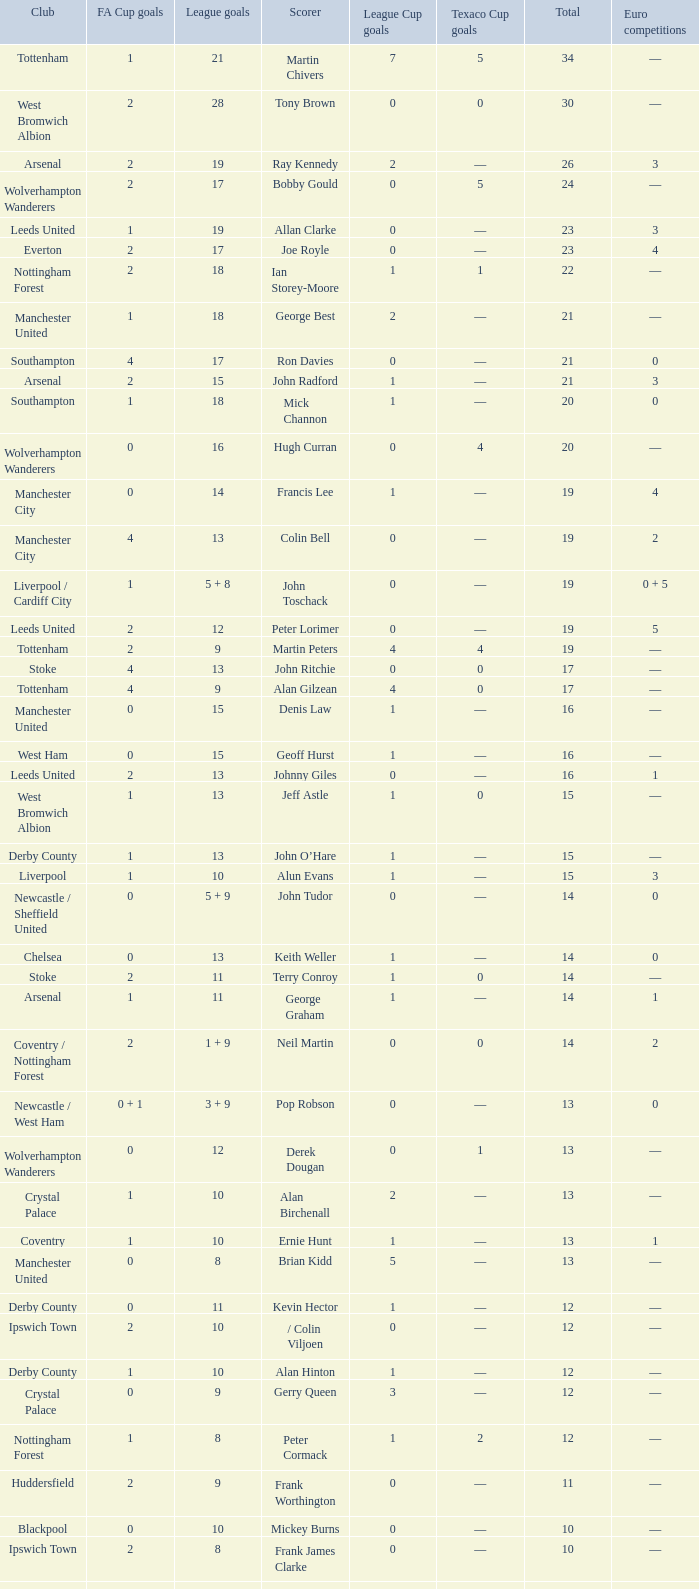What is the lowest League Cup Goals, when Scorer is Denis Law? 1.0. 